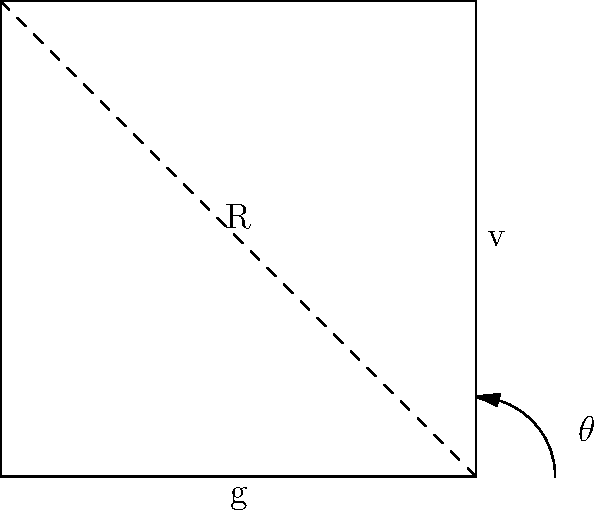A high-speed train is traveling at a velocity $v$ (m/s) on a curved track with radius $R$ (m). The maximum allowed lateral acceleration due to centripetal force is $a_{max}$ (m/s²), and the gravitational acceleration is $g$ (m/s²). Using the diagram, derive an expression for the minimum curve radius $R_{min}$ in terms of $v$, $a_{max}$, and $g$. Let's approach this step-by-step:

1) The centripetal acceleration of an object moving in a circular path is given by:
   $$a_c = \frac{v^2}{R}$$

2) In a banked curve, part of the centripetal force comes from the horizontal component of the normal force, and part from friction. The maximum allowed lateral acceleration $a_{max}$ represents the total centripetal acceleration that passengers can comfortably experience.

3) For safety and comfort, we want:
   $$\frac{v^2}{R} \leq a_{max}$$

4) To find the minimum radius, we consider the case of equality:
   $$\frac{v^2}{R_{min}} = a_{max}$$

5) Rearranging this equation:
   $$R_{min} = \frac{v^2}{a_{max}}$$

6) In practice, we often express $a_{max}$ as a fraction of $g$. Let's say $a_{max} = kg$, where $k$ is a factor less than 1:
   $$R_{min} = \frac{v^2}{kg}$$

7) Typical values for $k$ range from 0.1 to 0.15 for passenger comfort.

This formula gives us the minimum curve radius for a given speed, ensuring passenger comfort and safety.
Answer: $R_{min} = \frac{v^2}{kg}$ 